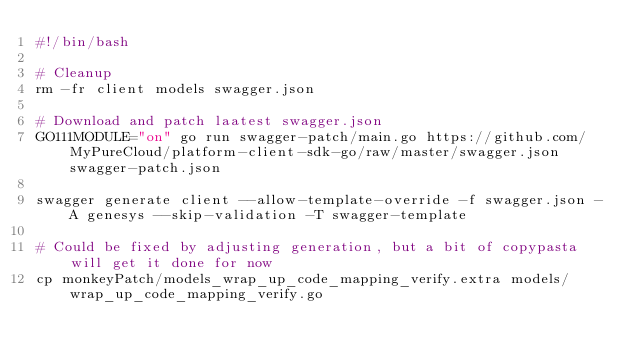<code> <loc_0><loc_0><loc_500><loc_500><_Bash_>#!/bin/bash

# Cleanup
rm -fr client models swagger.json

# Download and patch laatest swagger.json
GO111MODULE="on" go run swagger-patch/main.go https://github.com/MyPureCloud/platform-client-sdk-go/raw/master/swagger.json swagger-patch.json

swagger generate client --allow-template-override -f swagger.json -A genesys --skip-validation -T swagger-template

# Could be fixed by adjusting generation, but a bit of copypasta will get it done for now
cp monkeyPatch/models_wrap_up_code_mapping_verify.extra models/wrap_up_code_mapping_verify.go</code> 